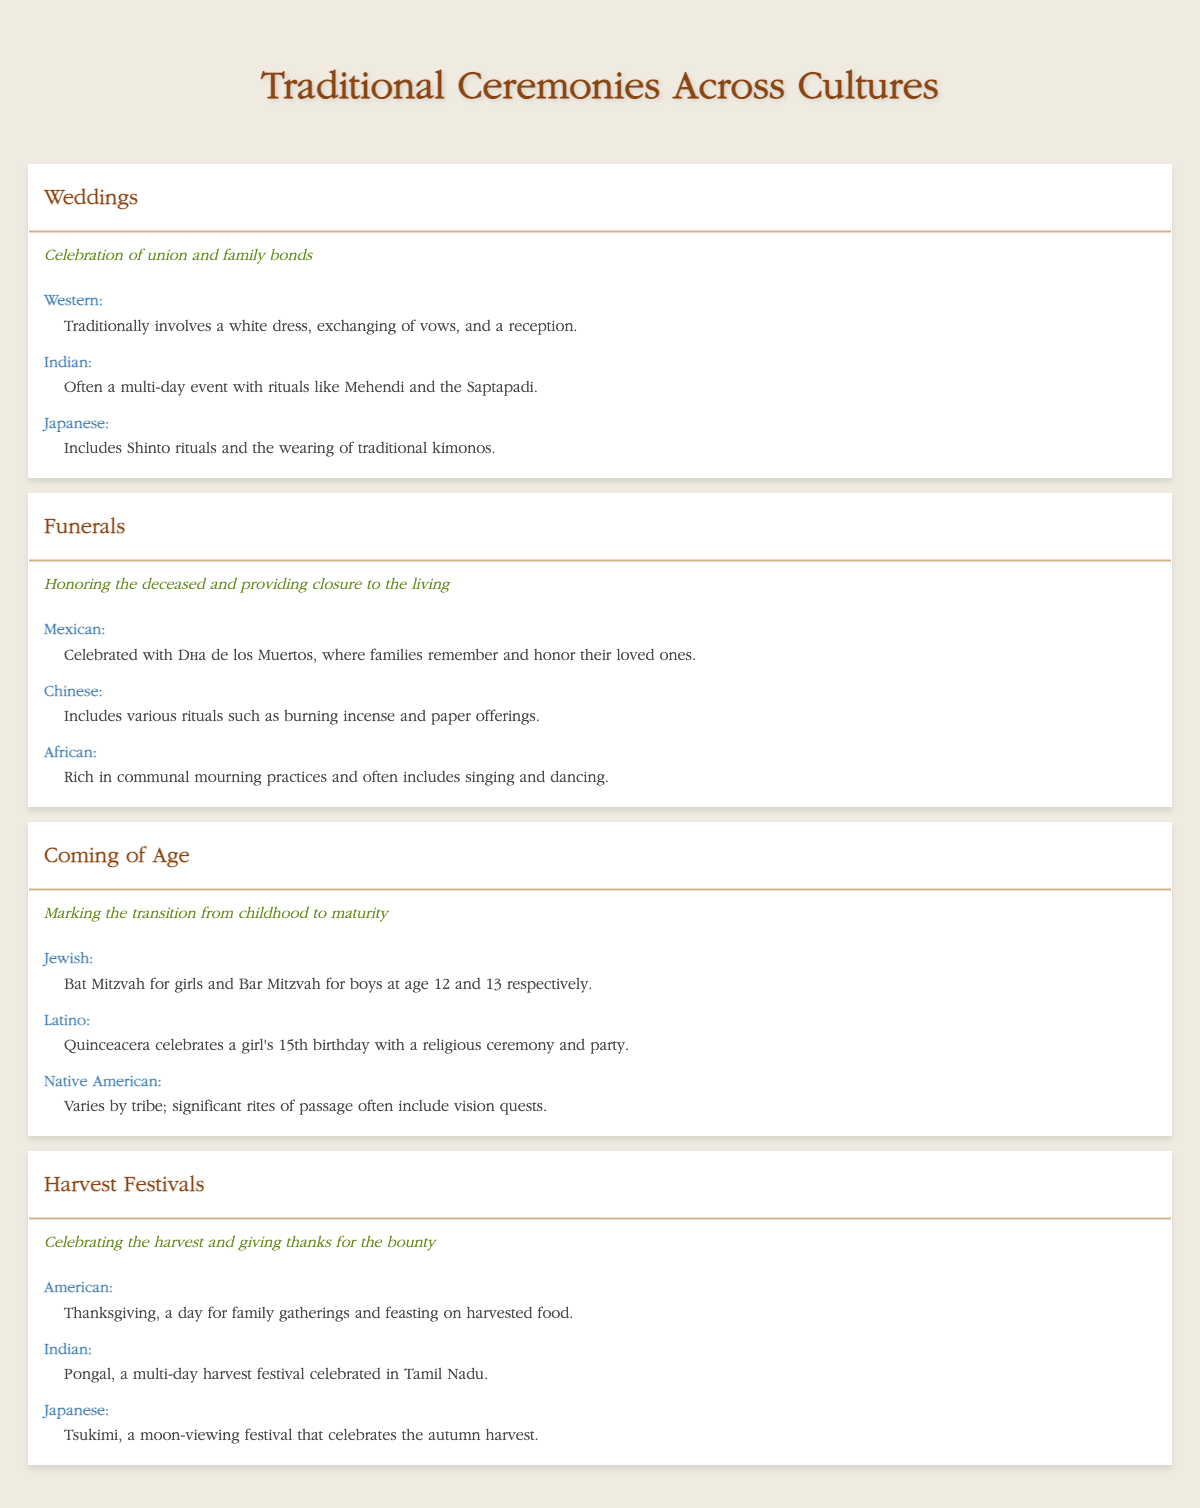What is the significance of weddings in traditional ceremonies? The significance of weddings, as described in the table, is to celebrate the union and family bonds. This fact can be found directly in the row corresponding to weddings.
Answer: Celebration of union and family bonds Which cultural example for funerals includes singing and dancing? The cultural example for funerals that includes singing and dancing is the African culture, which is listed in the funerals section of the table.
Answer: African culture How many cultural examples are listed for coming-of-age ceremonies? There are three cultural examples listed for coming-of-age ceremonies: Jewish, Latino, and Native American. This can be seen by counting the entries under the coming-of-age section.
Answer: 3 Are there any ceremonies that celebrate the harvest? Yes, there is a ceremony called Harvest Festivals that celebrates the harvest and gives thanks for the bounty, as stated in the table.
Answer: Yes What are the differences in the coming-of-age ceremonies between Jewish and Latino cultures? The Jewish coming-of-age ceremony includes Bat Mitzvah for girls and Bar Mitzvah for boys, while the Latino celebration is the Quinceañera for girls at age 15. By comparing the descriptions under each cultural example, the differences can be identified.
Answer: Bat Mitzvah and Bar Mitzvah compared to Quinceañera Which ceremony has its significance as honoring the deceased and providing closure to the living? The ceremony that signifies honoring the deceased and providing closure is Funerals, as noted in the significance column of the funerals row.
Answer: Funerals What is the total number of cultural examples across all ceremonies in the table? The total number of cultural examples is the sum of examples from each ceremony: Weddings (3) + Funerals (3) + Coming of Age (3) + Harvest Festivals (3) = 12 cultural examples total. Calculating this provides the complete count.
Answer: 12 Do the harvest festivals include a Japanese cultural example? Yes, the Harvest Festivals section includes a Japanese cultural example called Tsukimi, which celebrates the autumn harvest, as seen in the corresponding table row.
Answer: Yes How does the significance of coming-of-age ceremonies compare to weddings? The significance of coming-of-age ceremonies is about marking the transition from childhood to maturity, while weddings celebrate the union and family bonds. Comparing both significance lines in their respective rows shows this information.
Answer: Different significances 